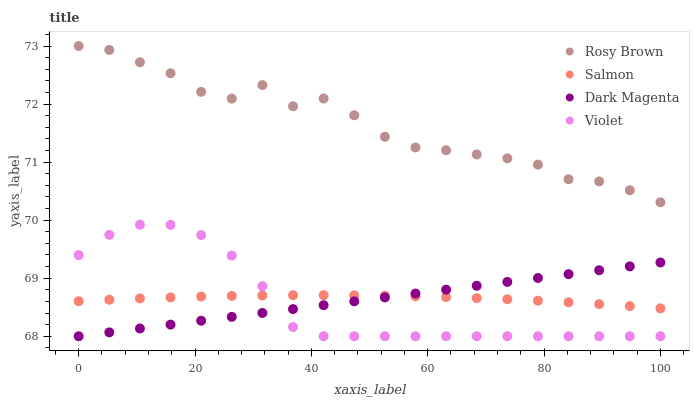Does Violet have the minimum area under the curve?
Answer yes or no. Yes. Does Rosy Brown have the maximum area under the curve?
Answer yes or no. Yes. Does Salmon have the minimum area under the curve?
Answer yes or no. No. Does Salmon have the maximum area under the curve?
Answer yes or no. No. Is Dark Magenta the smoothest?
Answer yes or no. Yes. Is Rosy Brown the roughest?
Answer yes or no. Yes. Is Salmon the smoothest?
Answer yes or no. No. Is Salmon the roughest?
Answer yes or no. No. Does Dark Magenta have the lowest value?
Answer yes or no. Yes. Does Salmon have the lowest value?
Answer yes or no. No. Does Rosy Brown have the highest value?
Answer yes or no. Yes. Does Dark Magenta have the highest value?
Answer yes or no. No. Is Dark Magenta less than Rosy Brown?
Answer yes or no. Yes. Is Rosy Brown greater than Violet?
Answer yes or no. Yes. Does Salmon intersect Dark Magenta?
Answer yes or no. Yes. Is Salmon less than Dark Magenta?
Answer yes or no. No. Is Salmon greater than Dark Magenta?
Answer yes or no. No. Does Dark Magenta intersect Rosy Brown?
Answer yes or no. No. 